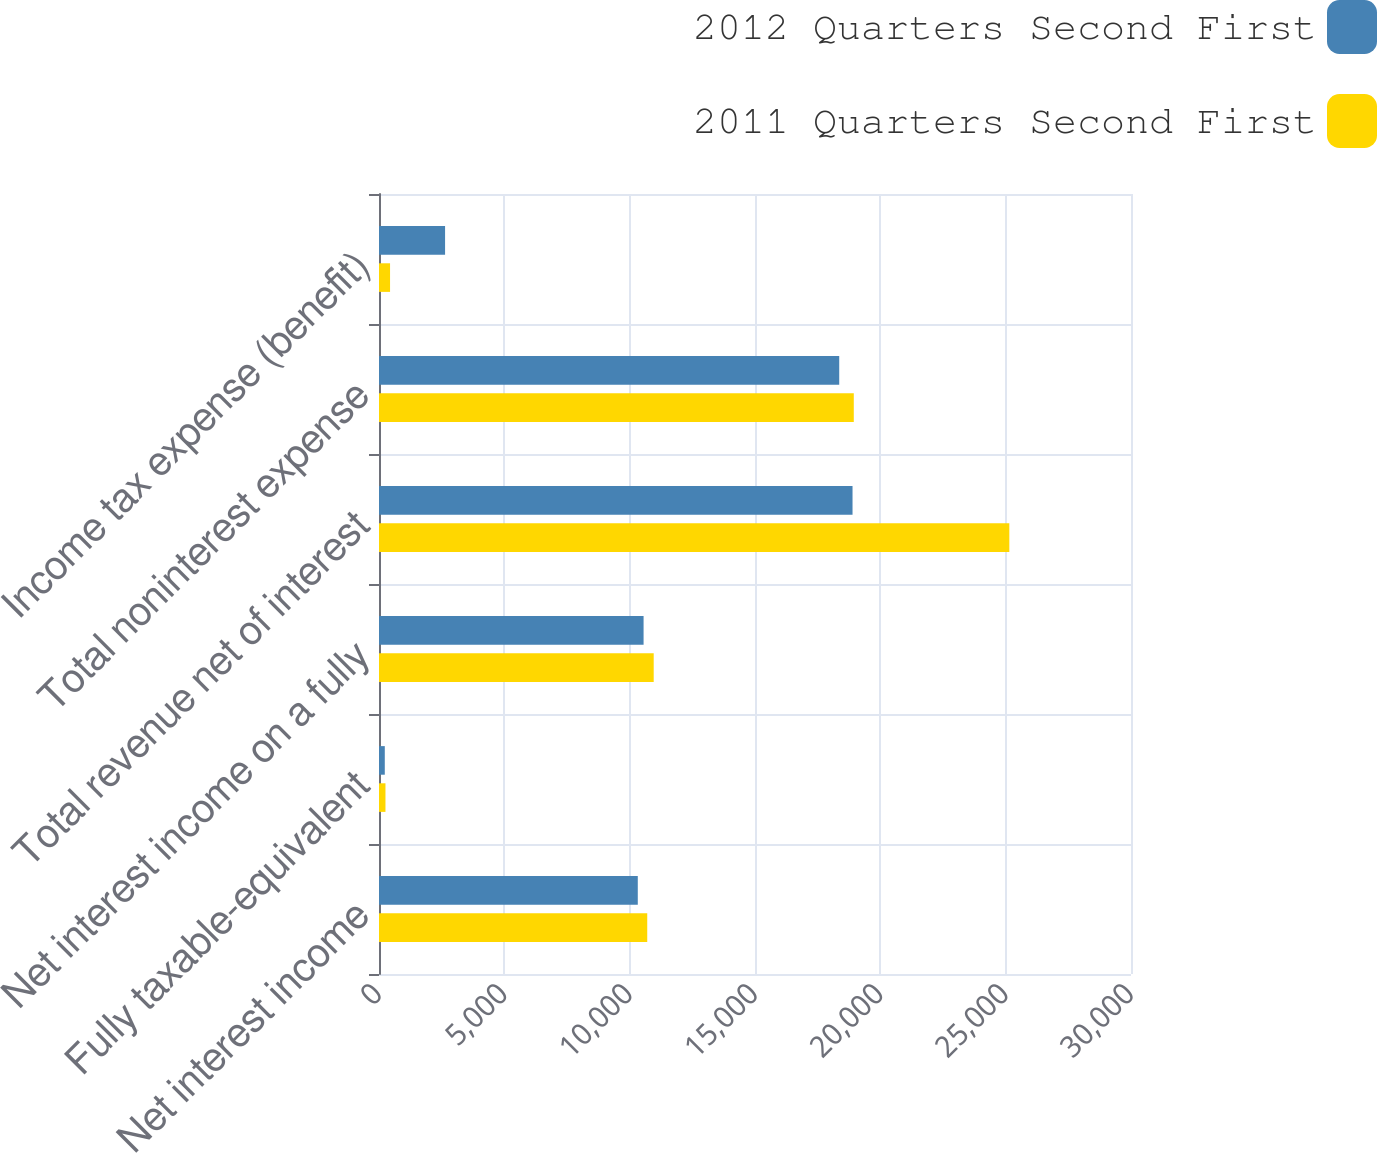Convert chart. <chart><loc_0><loc_0><loc_500><loc_500><stacked_bar_chart><ecel><fcel>Net interest income<fcel>Fully taxable-equivalent<fcel>Net interest income on a fully<fcel>Total revenue net of interest<fcel>Total noninterest expense<fcel>Income tax expense (benefit)<nl><fcel>2012 Quarters Second First<fcel>10324<fcel>231<fcel>10555<fcel>18891<fcel>18360<fcel>2636<nl><fcel>2011 Quarters Second First<fcel>10701<fcel>258<fcel>10959<fcel>25146<fcel>18941<fcel>441<nl></chart> 